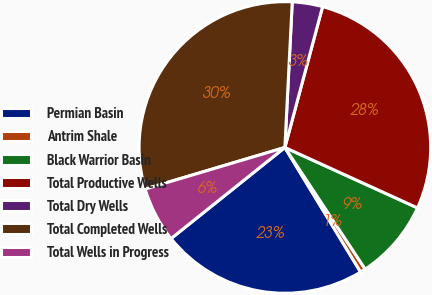Convert chart. <chart><loc_0><loc_0><loc_500><loc_500><pie_chart><fcel>Permian Basin<fcel>Antrim Shale<fcel>Black Warrior Basin<fcel>Total Productive Wells<fcel>Total Dry Wells<fcel>Total Completed Wells<fcel>Total Wells in Progress<nl><fcel>22.95%<fcel>0.59%<fcel>8.91%<fcel>27.64%<fcel>3.36%<fcel>30.41%<fcel>6.14%<nl></chart> 